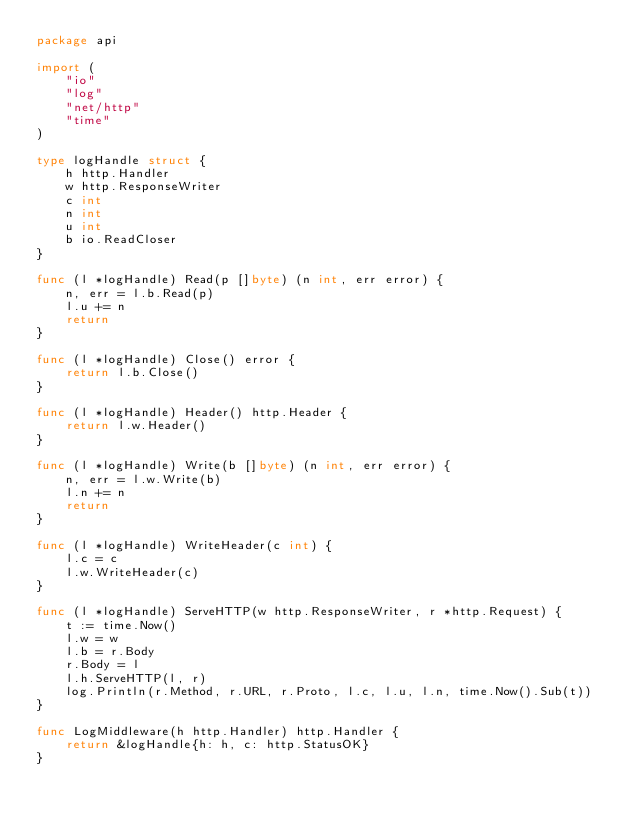<code> <loc_0><loc_0><loc_500><loc_500><_Go_>package api

import (
	"io"
	"log"
	"net/http"
	"time"
)

type logHandle struct {
	h http.Handler
	w http.ResponseWriter
	c int
	n int
	u int
	b io.ReadCloser
}

func (l *logHandle) Read(p []byte) (n int, err error) {
	n, err = l.b.Read(p)
	l.u += n
	return
}

func (l *logHandle) Close() error {
	return l.b.Close()
}

func (l *logHandle) Header() http.Header {
	return l.w.Header()
}

func (l *logHandle) Write(b []byte) (n int, err error) {
	n, err = l.w.Write(b)
	l.n += n
	return
}

func (l *logHandle) WriteHeader(c int) {
	l.c = c
	l.w.WriteHeader(c)
}

func (l *logHandle) ServeHTTP(w http.ResponseWriter, r *http.Request) {
	t := time.Now()
	l.w = w
	l.b = r.Body
	r.Body = l
	l.h.ServeHTTP(l, r)
	log.Println(r.Method, r.URL, r.Proto, l.c, l.u, l.n, time.Now().Sub(t))
}

func LogMiddleware(h http.Handler) http.Handler {
	return &logHandle{h: h, c: http.StatusOK}
}
</code> 